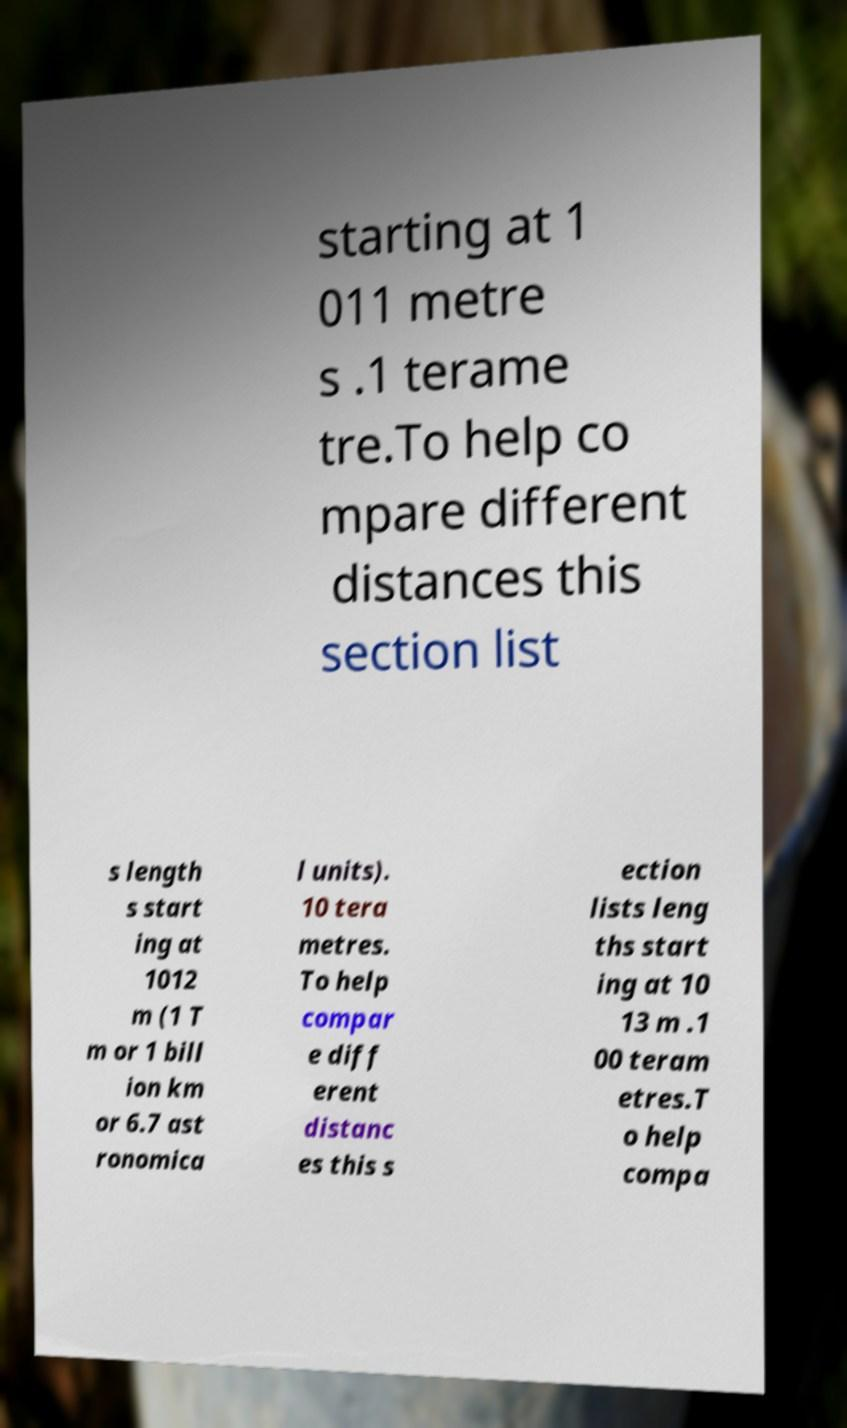I need the written content from this picture converted into text. Can you do that? starting at 1 011 metre s .1 terame tre.To help co mpare different distances this section list s length s start ing at 1012 m (1 T m or 1 bill ion km or 6.7 ast ronomica l units). 10 tera metres. To help compar e diff erent distanc es this s ection lists leng ths start ing at 10 13 m .1 00 teram etres.T o help compa 